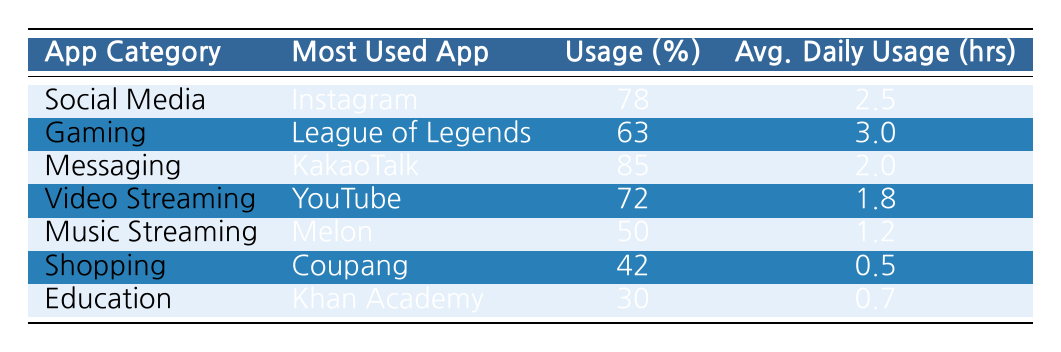What's the most used app in the Social Media category? According to the table, the most used app in the Social Media category is Instagram.
Answer: Instagram What percentage of Korean teens use KakaoTalk for messaging? The table shows that 85% of Korean teens use KakaoTalk for messaging.
Answer: 85% Which app has the highest average daily usage hours? By examining the table, League of Legends has the highest average daily usage hours at 3.0 hours.
Answer: 3.0 hours What is the average percentage usage of Music Streaming apps? The usage percentage for Music Streaming is 50%. Since there is only one app in this category, it is the same as the percentage usage of the app.
Answer: 50% Are more Korean teens likely to use Instagram than YouTube? Yes, 78% of teens use Instagram, while 72% use YouTube, indicating a higher usage for Instagram.
Answer: Yes What is the difference in average daily usage between Gaming and Video Streaming categories? League of Legends in the Gaming category has an average daily usage of 3.0 hours, and YouTube in Video Streaming has 1.8 hours. The difference is 3.0 - 1.8 = 1.2 hours.
Answer: 1.2 hours Is Melon more popular than Coupang among the Korean teens? No, Melon is used by 50%, while Coupang has a usage percentage of only 42%, making Melon more popular.
Answer: No What is the total percentage usage of the most used apps in Social Media and Messaging categories? For Social Media, Instagram has 78% and for Messaging, KakaoTalk has 85%. Adding them together gives 78 + 85 = 163%.
Answer: 163% Which app category has the lowest average daily usage hours? Looking at the table, the Shopping category (Coupang) has the lowest average daily usage at 0.5 hours.
Answer: Shopping category (Coupang) 